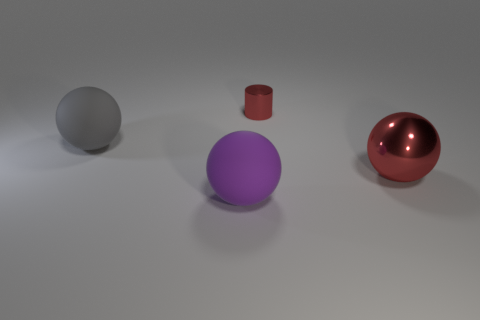There is a ball that is on the right side of the cylinder; what color is it? red 